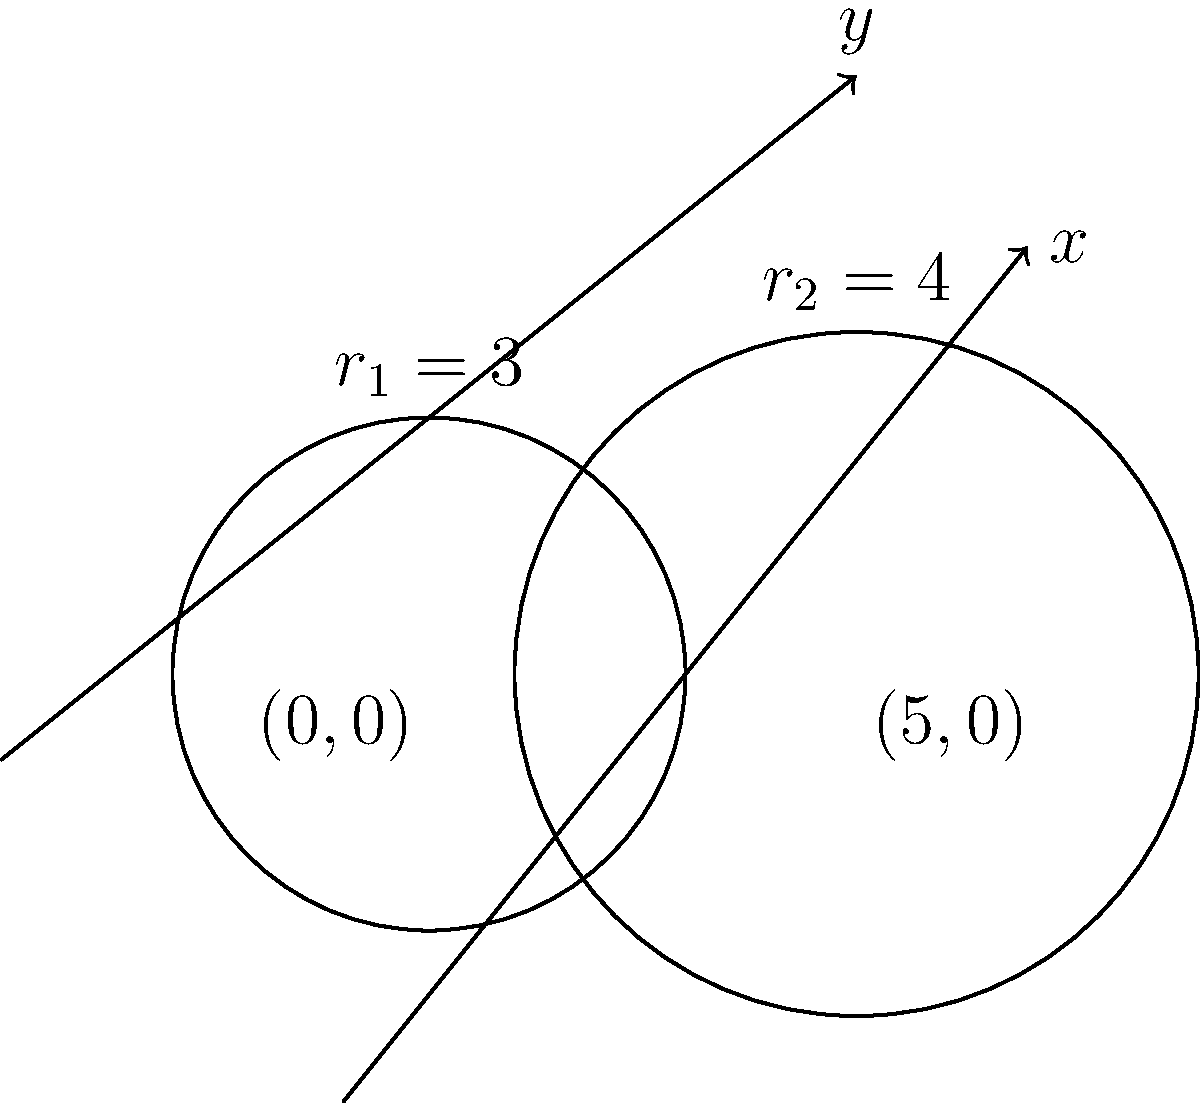In your interactive solar system model, you're simulating two satellite orbits around a planet. The orbits are represented as circles in a 2D coordinate system. The first orbit is centered at $(0,0)$ with a radius of 3 units, while the second orbit is centered at $(5,0)$ with a radius of 4 units. Find the $y$-coordinates of the intersection points of these two orbits. Let's approach this step-by-step:

1) The equation of the first circle (orbit) is:
   $x^2 + y^2 = 3^2 = 9$

2) The equation of the second circle (orbit) is:
   $(x-5)^2 + y^2 = 4^2 = 16$

3) To find the intersection points, we need to solve these equations simultaneously.

4) Expand the second equation:
   $x^2 - 10x + 25 + y^2 = 16$

5) Subtract the first equation from this:
   $x^2 - 10x + 25 + y^2 - (x^2 + y^2) = 16 - 9$
   $-10x + 25 = 7$
   $-10x = -18$
   $x = 1.8$

6) Now substitute this x-value back into the equation of the first circle:
   $(1.8)^2 + y^2 = 9$
   $3.24 + y^2 = 9$
   $y^2 = 5.76$
   $y = \pm \sqrt{5.76} = \pm 2.4$

7) Therefore, the y-coordinates of the intersection points are 2.4 and -2.4.
Answer: $\pm 2.4$ 